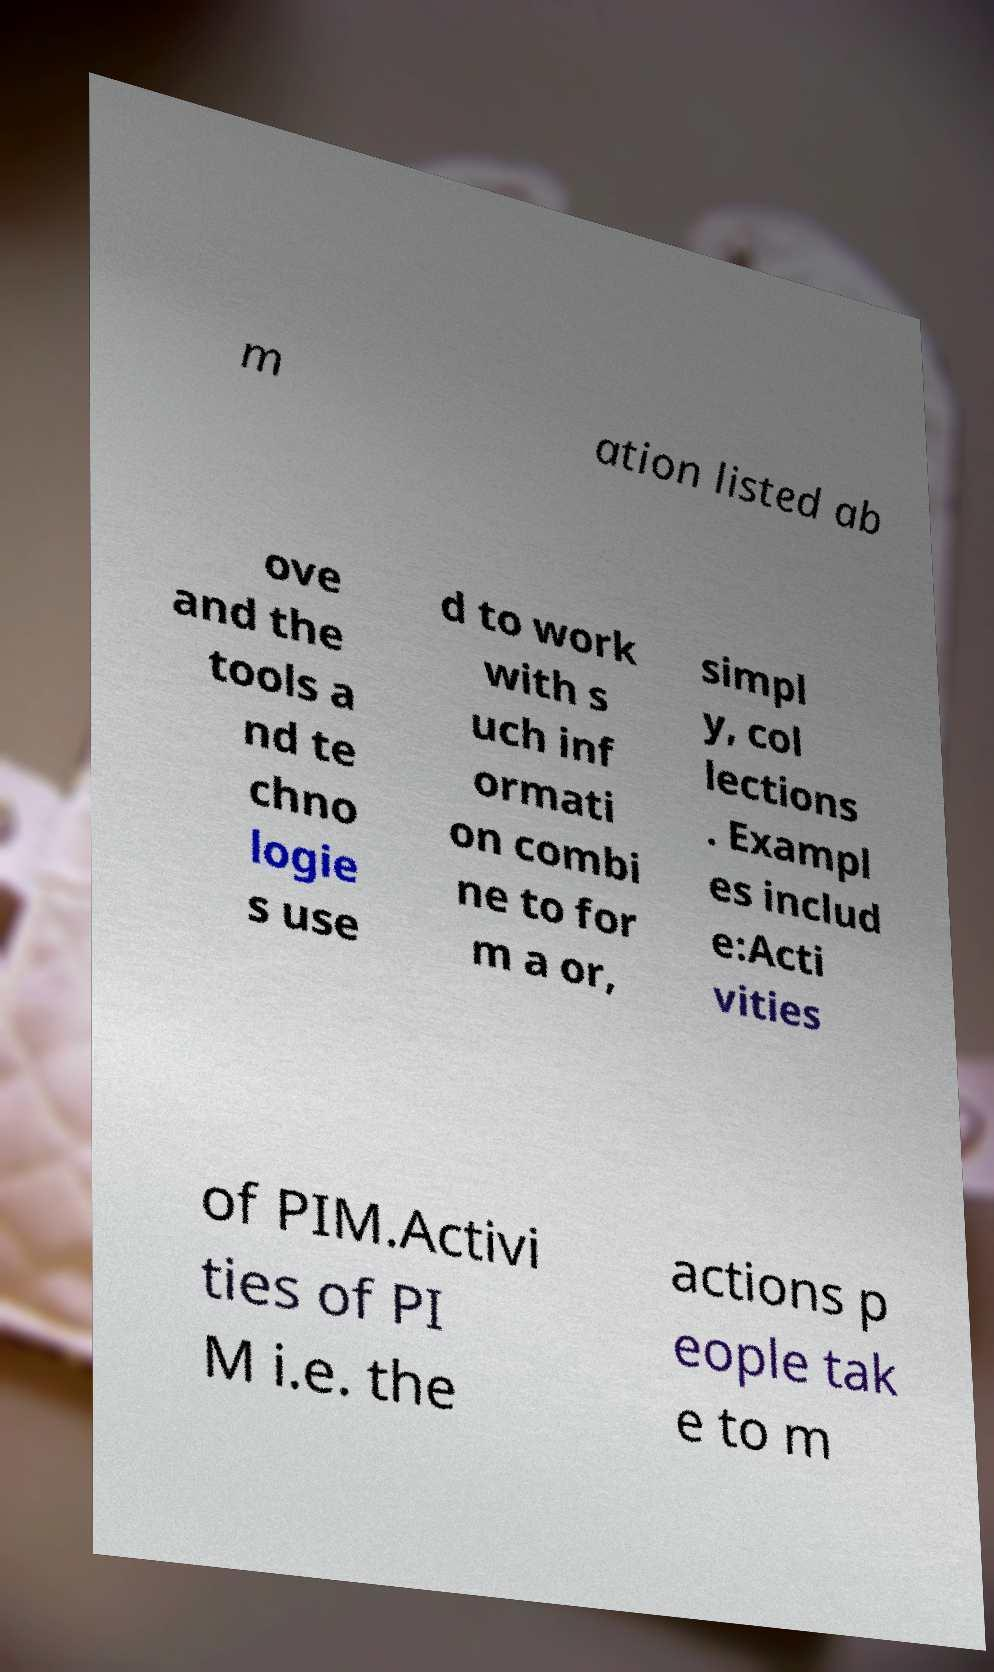Please identify and transcribe the text found in this image. m ation listed ab ove and the tools a nd te chno logie s use d to work with s uch inf ormati on combi ne to for m a or, simpl y, col lections . Exampl es includ e:Acti vities of PIM.Activi ties of PI M i.e. the actions p eople tak e to m 